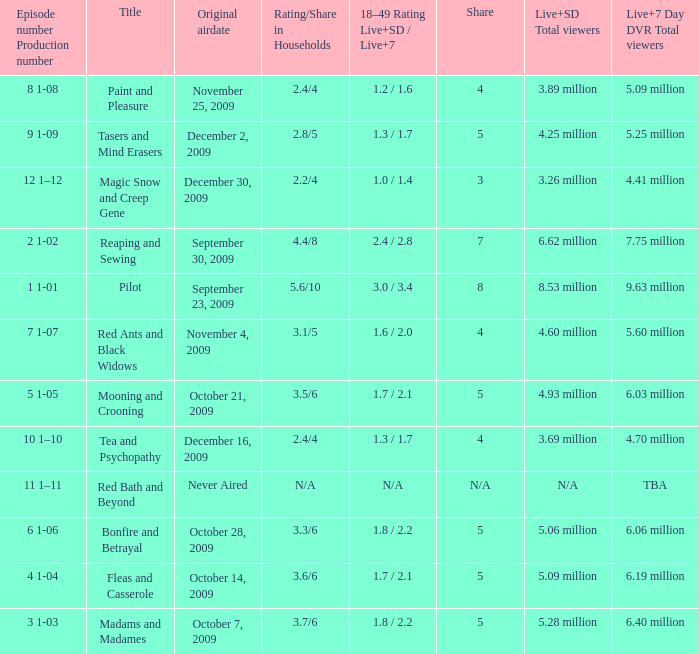How many total viewers (combined Live and SD) watched the episode with a share of 8? 9.63 million. 